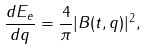Convert formula to latex. <formula><loc_0><loc_0><loc_500><loc_500>\frac { d E _ { e } } { d q } = \frac { 4 } { \pi } | B ( t , q ) | ^ { 2 } ,</formula> 